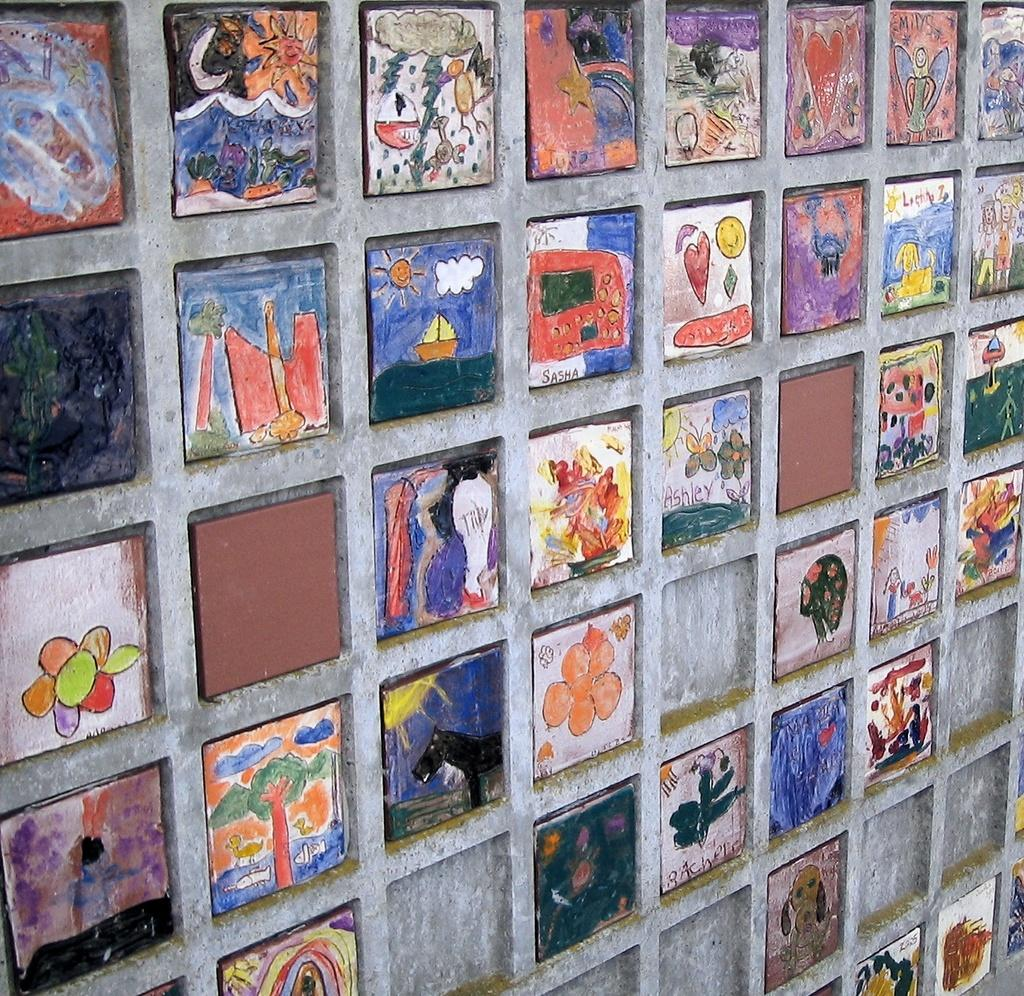What can be seen on the wall in the image? There are paintings on the wall in the image. What type of pipe can be seen in the ocean in the image? There is no pipe or ocean present in the image; it only features paintings on the wall. What songs are being sung by the people in the image? There are no people or songs present in the image; it only features paintings on the wall. 